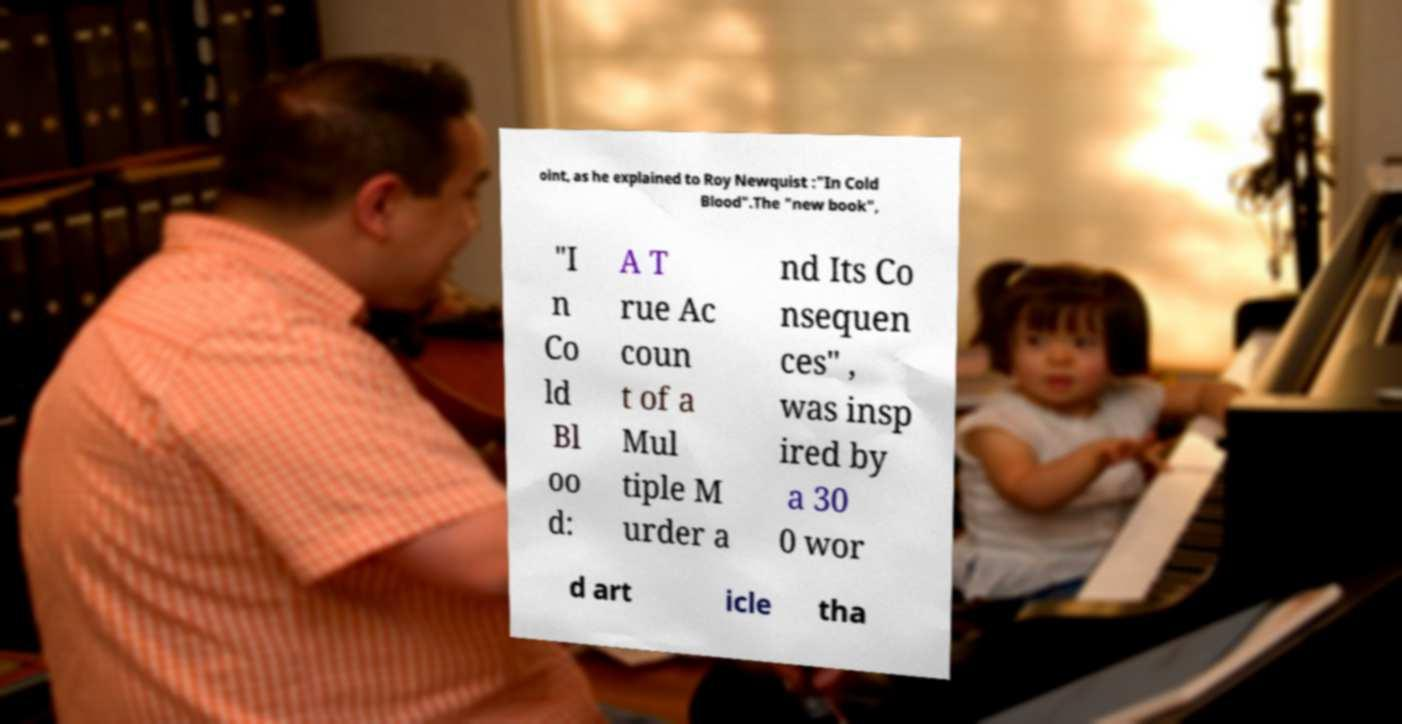Can you accurately transcribe the text from the provided image for me? oint, as he explained to Roy Newquist :"In Cold Blood".The "new book", "I n Co ld Bl oo d: A T rue Ac coun t of a Mul tiple M urder a nd Its Co nsequen ces" , was insp ired by a 30 0 wor d art icle tha 